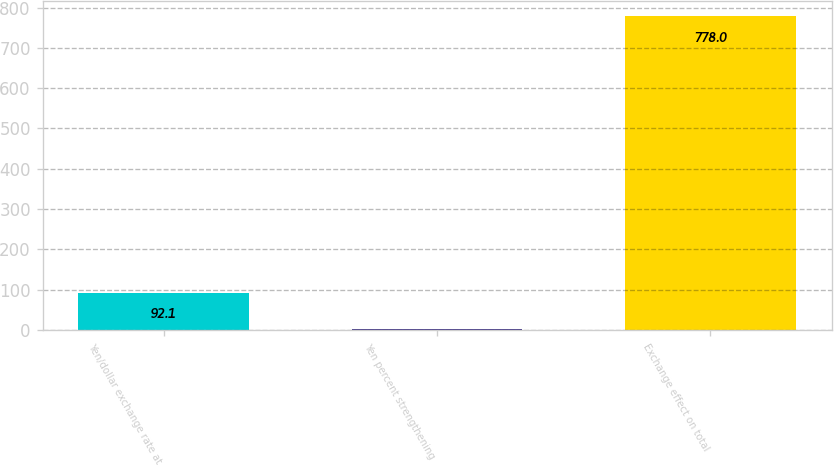Convert chart. <chart><loc_0><loc_0><loc_500><loc_500><bar_chart><fcel>Yen/dollar exchange rate at<fcel>Yen percent strengthening<fcel>Exchange effect on total<nl><fcel>92.1<fcel>1.2<fcel>778<nl></chart> 